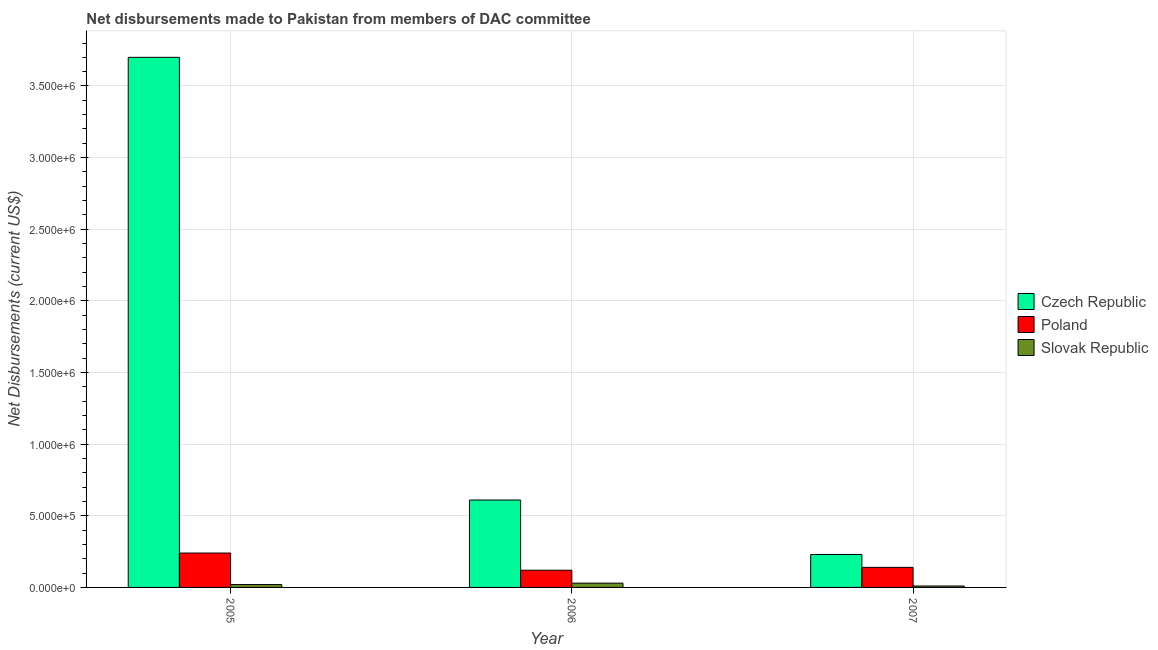How many different coloured bars are there?
Your response must be concise. 3. Are the number of bars per tick equal to the number of legend labels?
Provide a succinct answer. Yes. How many bars are there on the 3rd tick from the right?
Your answer should be compact. 3. What is the label of the 2nd group of bars from the left?
Your answer should be compact. 2006. In how many cases, is the number of bars for a given year not equal to the number of legend labels?
Keep it short and to the point. 0. What is the net disbursements made by czech republic in 2007?
Keep it short and to the point. 2.30e+05. Across all years, what is the maximum net disbursements made by slovak republic?
Your response must be concise. 3.00e+04. Across all years, what is the minimum net disbursements made by slovak republic?
Provide a short and direct response. 10000. What is the total net disbursements made by czech republic in the graph?
Your answer should be very brief. 4.54e+06. What is the difference between the net disbursements made by slovak republic in 2005 and that in 2007?
Keep it short and to the point. 10000. What is the difference between the net disbursements made by slovak republic in 2006 and the net disbursements made by poland in 2005?
Give a very brief answer. 10000. What is the average net disbursements made by poland per year?
Keep it short and to the point. 1.67e+05. What is the ratio of the net disbursements made by czech republic in 2005 to that in 2006?
Provide a short and direct response. 6.07. What is the difference between the highest and the second highest net disbursements made by czech republic?
Offer a terse response. 3.09e+06. What is the difference between the highest and the lowest net disbursements made by czech republic?
Give a very brief answer. 3.47e+06. Is the sum of the net disbursements made by czech republic in 2005 and 2006 greater than the maximum net disbursements made by slovak republic across all years?
Ensure brevity in your answer.  Yes. What does the 1st bar from the right in 2006 represents?
Provide a succinct answer. Slovak Republic. Is it the case that in every year, the sum of the net disbursements made by czech republic and net disbursements made by poland is greater than the net disbursements made by slovak republic?
Provide a succinct answer. Yes. How many years are there in the graph?
Provide a short and direct response. 3. Does the graph contain any zero values?
Keep it short and to the point. No. Where does the legend appear in the graph?
Offer a very short reply. Center right. How are the legend labels stacked?
Offer a terse response. Vertical. What is the title of the graph?
Offer a very short reply. Net disbursements made to Pakistan from members of DAC committee. What is the label or title of the X-axis?
Offer a terse response. Year. What is the label or title of the Y-axis?
Keep it short and to the point. Net Disbursements (current US$). What is the Net Disbursements (current US$) in Czech Republic in 2005?
Ensure brevity in your answer.  3.70e+06. What is the Net Disbursements (current US$) in Slovak Republic in 2006?
Provide a short and direct response. 3.00e+04. What is the Net Disbursements (current US$) in Czech Republic in 2007?
Offer a very short reply. 2.30e+05. What is the Net Disbursements (current US$) of Poland in 2007?
Ensure brevity in your answer.  1.40e+05. Across all years, what is the maximum Net Disbursements (current US$) of Czech Republic?
Provide a short and direct response. 3.70e+06. Across all years, what is the minimum Net Disbursements (current US$) of Poland?
Your answer should be compact. 1.20e+05. What is the total Net Disbursements (current US$) of Czech Republic in the graph?
Make the answer very short. 4.54e+06. What is the total Net Disbursements (current US$) in Poland in the graph?
Keep it short and to the point. 5.00e+05. What is the difference between the Net Disbursements (current US$) in Czech Republic in 2005 and that in 2006?
Offer a terse response. 3.09e+06. What is the difference between the Net Disbursements (current US$) in Czech Republic in 2005 and that in 2007?
Your answer should be compact. 3.47e+06. What is the difference between the Net Disbursements (current US$) in Poland in 2005 and that in 2007?
Offer a terse response. 1.00e+05. What is the difference between the Net Disbursements (current US$) in Slovak Republic in 2005 and that in 2007?
Your answer should be very brief. 10000. What is the difference between the Net Disbursements (current US$) in Czech Republic in 2006 and that in 2007?
Provide a succinct answer. 3.80e+05. What is the difference between the Net Disbursements (current US$) in Poland in 2006 and that in 2007?
Your answer should be very brief. -2.00e+04. What is the difference between the Net Disbursements (current US$) of Slovak Republic in 2006 and that in 2007?
Provide a succinct answer. 2.00e+04. What is the difference between the Net Disbursements (current US$) in Czech Republic in 2005 and the Net Disbursements (current US$) in Poland in 2006?
Provide a short and direct response. 3.58e+06. What is the difference between the Net Disbursements (current US$) of Czech Republic in 2005 and the Net Disbursements (current US$) of Slovak Republic in 2006?
Provide a short and direct response. 3.67e+06. What is the difference between the Net Disbursements (current US$) of Czech Republic in 2005 and the Net Disbursements (current US$) of Poland in 2007?
Keep it short and to the point. 3.56e+06. What is the difference between the Net Disbursements (current US$) in Czech Republic in 2005 and the Net Disbursements (current US$) in Slovak Republic in 2007?
Ensure brevity in your answer.  3.69e+06. What is the difference between the Net Disbursements (current US$) in Czech Republic in 2006 and the Net Disbursements (current US$) in Poland in 2007?
Offer a terse response. 4.70e+05. What is the difference between the Net Disbursements (current US$) in Czech Republic in 2006 and the Net Disbursements (current US$) in Slovak Republic in 2007?
Your answer should be very brief. 6.00e+05. What is the average Net Disbursements (current US$) in Czech Republic per year?
Your answer should be compact. 1.51e+06. What is the average Net Disbursements (current US$) in Poland per year?
Ensure brevity in your answer.  1.67e+05. What is the average Net Disbursements (current US$) of Slovak Republic per year?
Your answer should be compact. 2.00e+04. In the year 2005, what is the difference between the Net Disbursements (current US$) of Czech Republic and Net Disbursements (current US$) of Poland?
Provide a succinct answer. 3.46e+06. In the year 2005, what is the difference between the Net Disbursements (current US$) of Czech Republic and Net Disbursements (current US$) of Slovak Republic?
Provide a short and direct response. 3.68e+06. In the year 2006, what is the difference between the Net Disbursements (current US$) of Czech Republic and Net Disbursements (current US$) of Slovak Republic?
Your response must be concise. 5.80e+05. In the year 2006, what is the difference between the Net Disbursements (current US$) in Poland and Net Disbursements (current US$) in Slovak Republic?
Offer a very short reply. 9.00e+04. In the year 2007, what is the difference between the Net Disbursements (current US$) in Czech Republic and Net Disbursements (current US$) in Slovak Republic?
Make the answer very short. 2.20e+05. What is the ratio of the Net Disbursements (current US$) of Czech Republic in 2005 to that in 2006?
Your answer should be very brief. 6.07. What is the ratio of the Net Disbursements (current US$) of Poland in 2005 to that in 2006?
Give a very brief answer. 2. What is the ratio of the Net Disbursements (current US$) in Slovak Republic in 2005 to that in 2006?
Provide a short and direct response. 0.67. What is the ratio of the Net Disbursements (current US$) of Czech Republic in 2005 to that in 2007?
Your answer should be compact. 16.09. What is the ratio of the Net Disbursements (current US$) in Poland in 2005 to that in 2007?
Provide a short and direct response. 1.71. What is the ratio of the Net Disbursements (current US$) of Slovak Republic in 2005 to that in 2007?
Make the answer very short. 2. What is the ratio of the Net Disbursements (current US$) of Czech Republic in 2006 to that in 2007?
Your response must be concise. 2.65. What is the ratio of the Net Disbursements (current US$) in Poland in 2006 to that in 2007?
Your answer should be compact. 0.86. What is the difference between the highest and the second highest Net Disbursements (current US$) in Czech Republic?
Provide a succinct answer. 3.09e+06. What is the difference between the highest and the second highest Net Disbursements (current US$) in Slovak Republic?
Offer a very short reply. 10000. What is the difference between the highest and the lowest Net Disbursements (current US$) in Czech Republic?
Your answer should be very brief. 3.47e+06. What is the difference between the highest and the lowest Net Disbursements (current US$) of Poland?
Provide a short and direct response. 1.20e+05. 